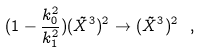Convert formula to latex. <formula><loc_0><loc_0><loc_500><loc_500>( 1 - \frac { k _ { 0 } ^ { 2 } } { k _ { 1 } ^ { 2 } } ) ( \tilde { X } ^ { 3 } ) ^ { 2 } \rightarrow ( \tilde { X } ^ { 3 } ) ^ { 2 } \ ,</formula> 